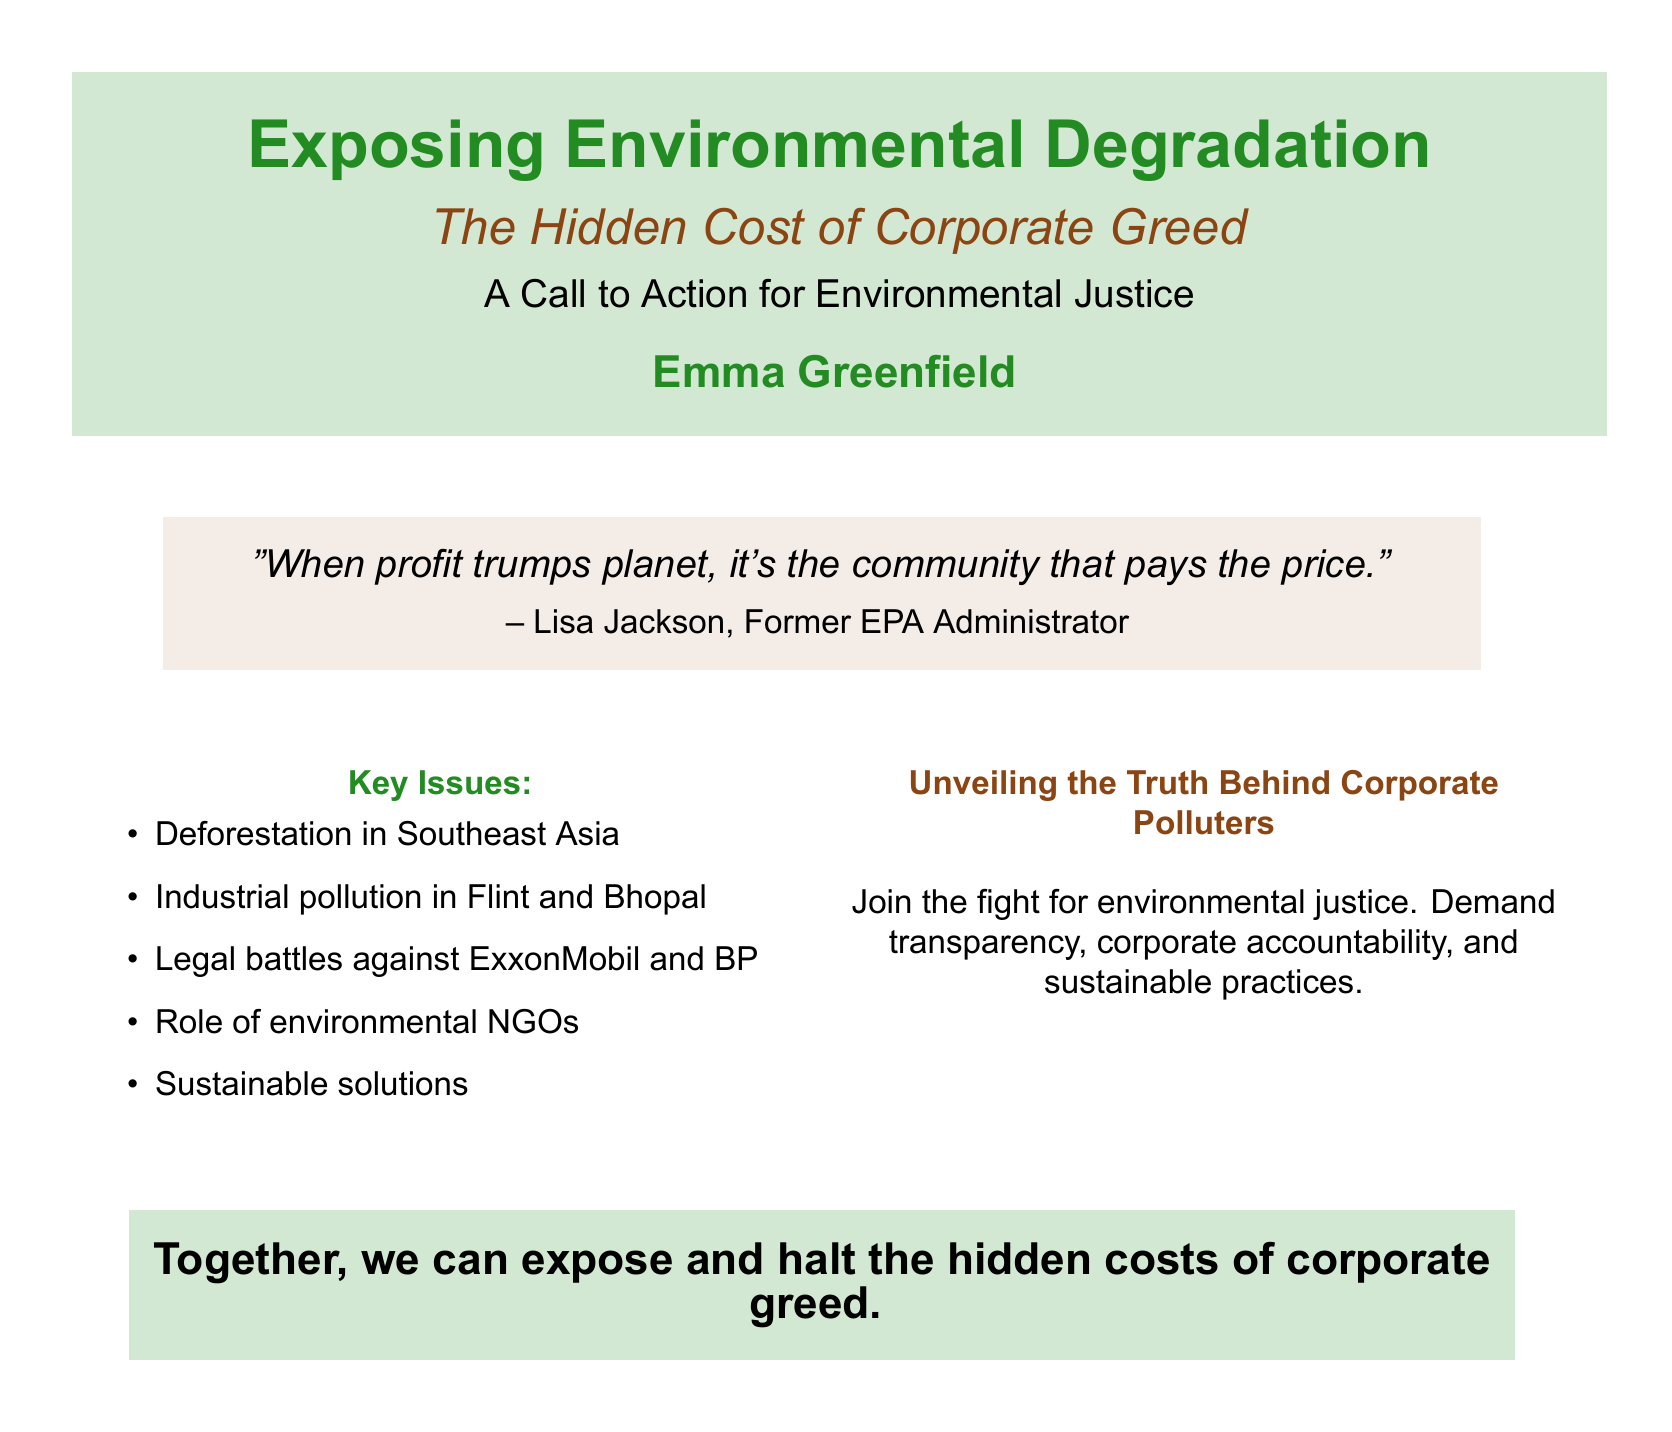What is the title of the book? The title is prominently displayed on the cover as the main focus.
Answer: Exposing Environmental Degradation Who is the author of the book? The author's name appears below the title in a larger font.
Answer: Emma Greenfield What is the subtitle of the book? The subtitle provides further context about the themes discussed in the book.
Answer: The Hidden Cost of Corporate Greed What quote is featured on the cover? The quote appears in italics and is attributed to a notable figure, offering insight into the book's message.
Answer: "When profit trumps planet, it's the community that pays the price." Which environmental issue is mentioned regarding Southeast Asia? The specific issue is listed as one of the key topics highlighted on the cover.
Answer: Deforestation What type of justice does the book call for? The book promotes a specific type of justice that relates to environmental concerns.
Answer: Environmental justice Name one company involved in legal battles mentioned in the book. The cover explicitly mentions these companies as part of the context in the document.
Answer: ExxonMobil What is one role outlined for environmental organizations? The cover indicates the roles that these organizations play in environmental issues.
Answer: Role of environmental NGOs 